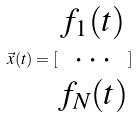<formula> <loc_0><loc_0><loc_500><loc_500>\vec { x } ( t ) = [ \begin{matrix} f _ { 1 } ( t ) \\ \cdot \cdot \cdot \\ f _ { N } ( t ) \end{matrix} ]</formula> 